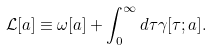<formula> <loc_0><loc_0><loc_500><loc_500>\mathcal { L } [ a ] \equiv \omega [ a ] + \int _ { 0 } ^ { \infty } d \tau \gamma [ \tau ; a ] .</formula> 